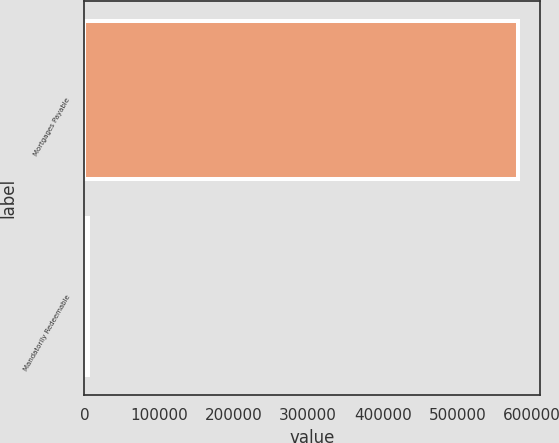<chart> <loc_0><loc_0><loc_500><loc_500><bar_chart><fcel>Mortgages Payable<fcel>Mandatorily Redeemable<nl><fcel>581846<fcel>4436<nl></chart> 